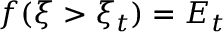<formula> <loc_0><loc_0><loc_500><loc_500>f ( \xi > \xi _ { t } ) = E _ { t }</formula> 